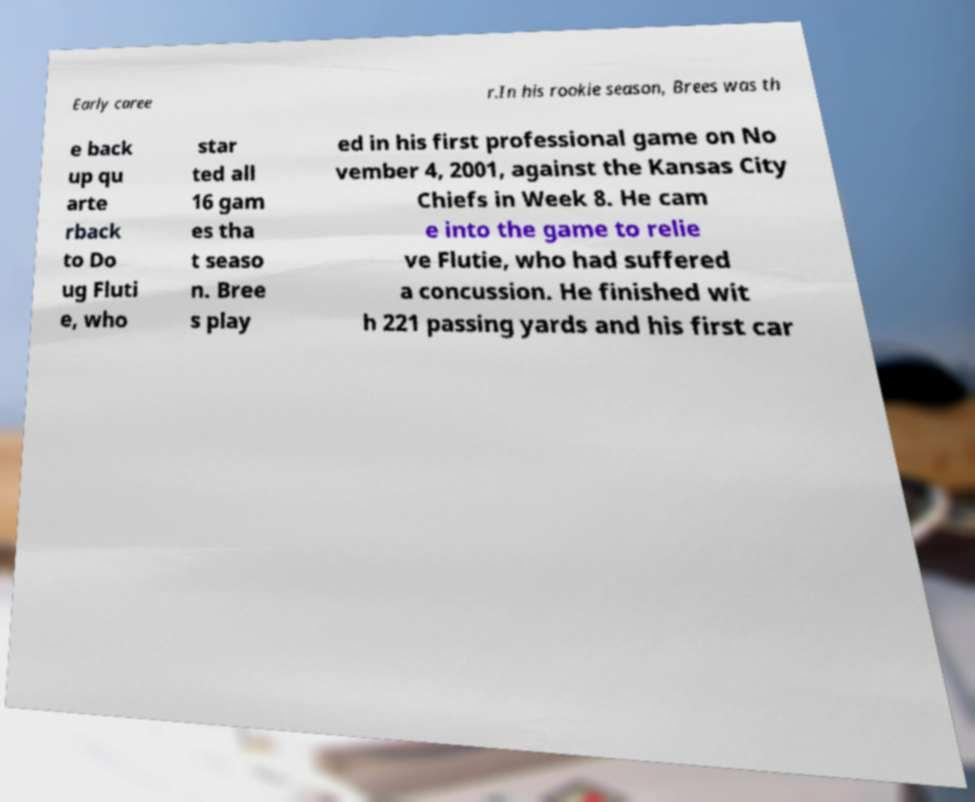What messages or text are displayed in this image? I need them in a readable, typed format. Early caree r.In his rookie season, Brees was th e back up qu arte rback to Do ug Fluti e, who star ted all 16 gam es tha t seaso n. Bree s play ed in his first professional game on No vember 4, 2001, against the Kansas City Chiefs in Week 8. He cam e into the game to relie ve Flutie, who had suffered a concussion. He finished wit h 221 passing yards and his first car 